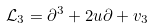<formula> <loc_0><loc_0><loc_500><loc_500>{ \mathcal { L } } _ { 3 } = \partial ^ { 3 } + 2 u \partial + v _ { 3 }</formula> 